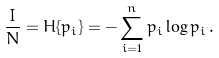Convert formula to latex. <formula><loc_0><loc_0><loc_500><loc_500>\frac { I } { N } = H \{ p _ { i } \} = - \sum _ { i = 1 } ^ { n } p _ { i } \log p _ { i } \, .</formula> 